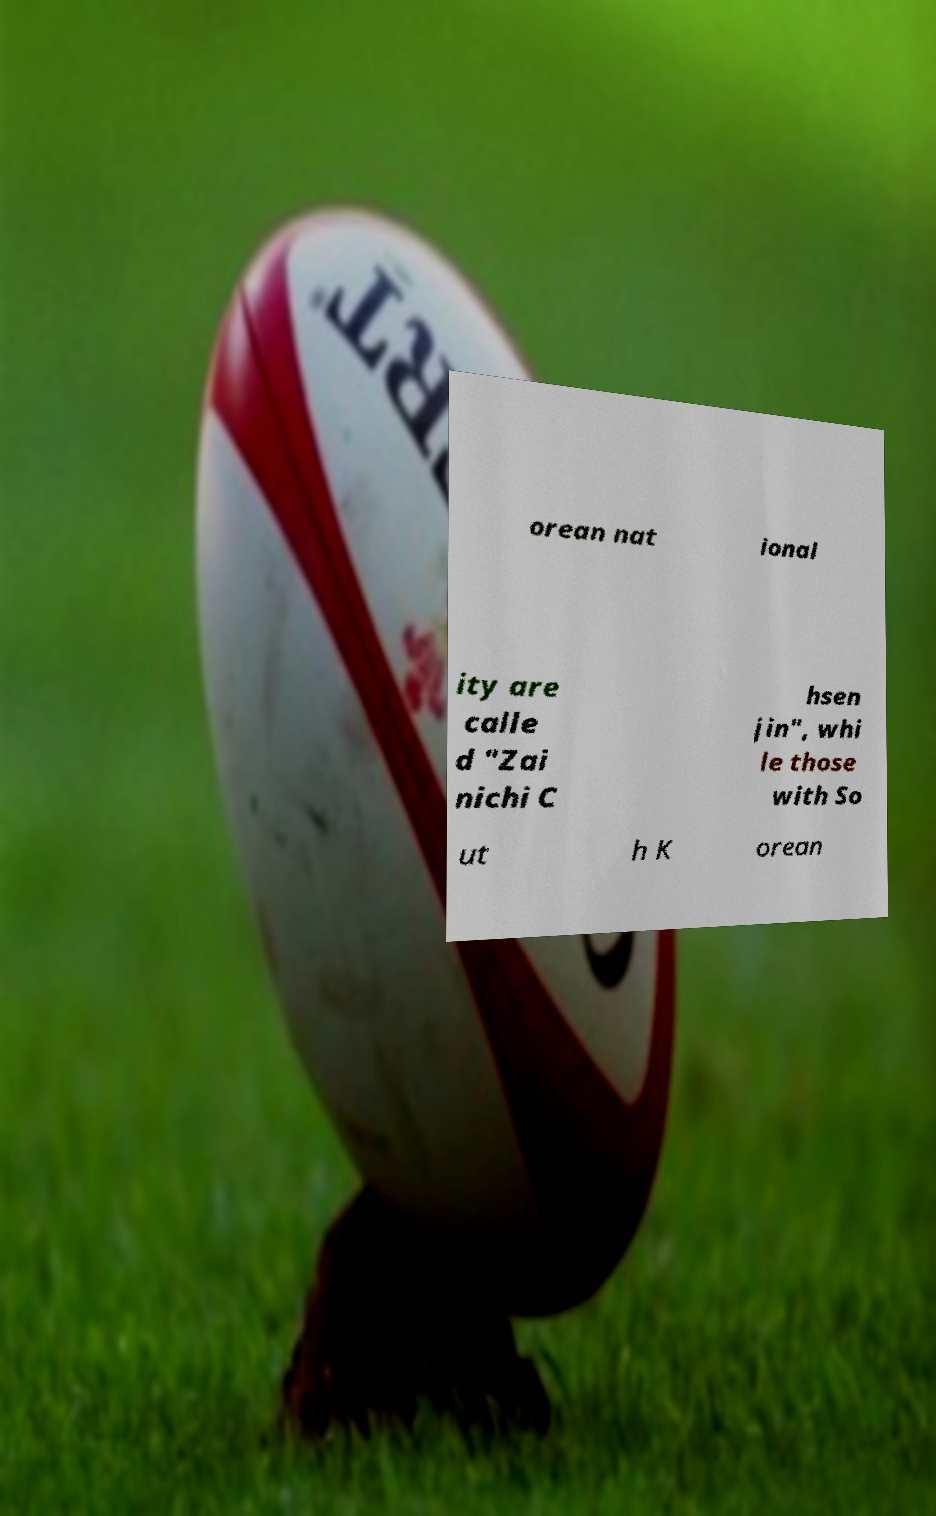For documentation purposes, I need the text within this image transcribed. Could you provide that? orean nat ional ity are calle d "Zai nichi C hsen jin", whi le those with So ut h K orean 